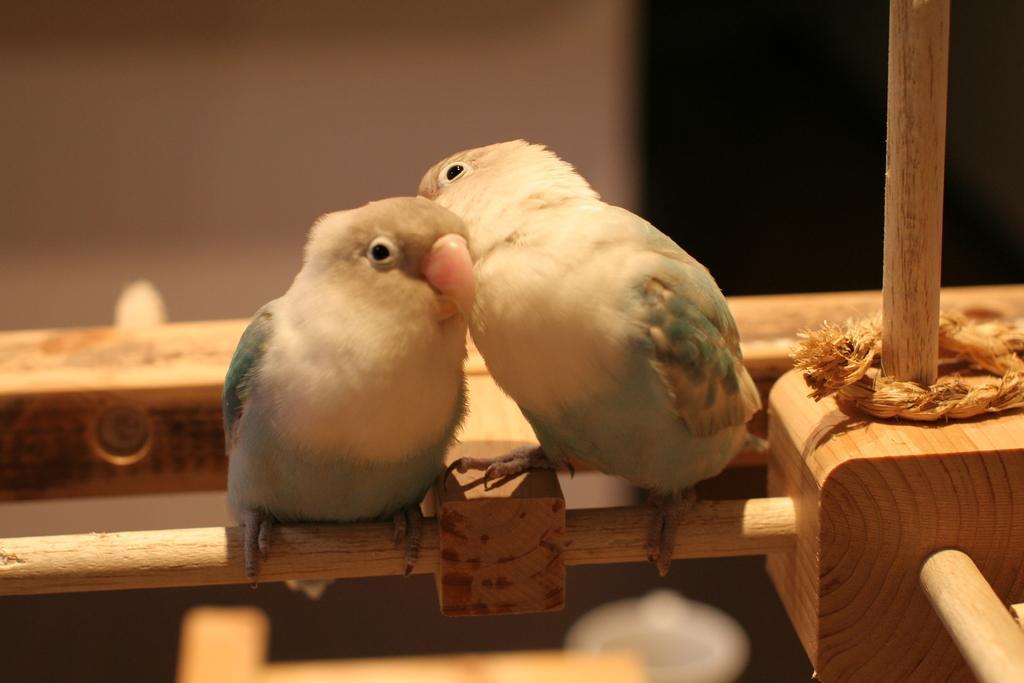Can you describe this image briefly? In this image I can see two birds on a wooden object. On the right side there is a rope. 